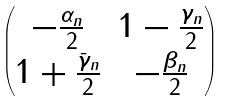<formula> <loc_0><loc_0><loc_500><loc_500>\begin{pmatrix} - \frac { \alpha _ { n } } { 2 } & 1 - \frac { \gamma _ { n } } { 2 } \\ 1 + \frac { \bar { \gamma } _ { n } } { 2 } & - \frac { \beta _ { n } } { 2 } \end{pmatrix}</formula> 